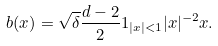Convert formula to latex. <formula><loc_0><loc_0><loc_500><loc_500>b ( x ) = \sqrt { \delta } \frac { d - 2 } { 2 } 1 _ { | x | < 1 } | x | ^ { - 2 } x .</formula> 